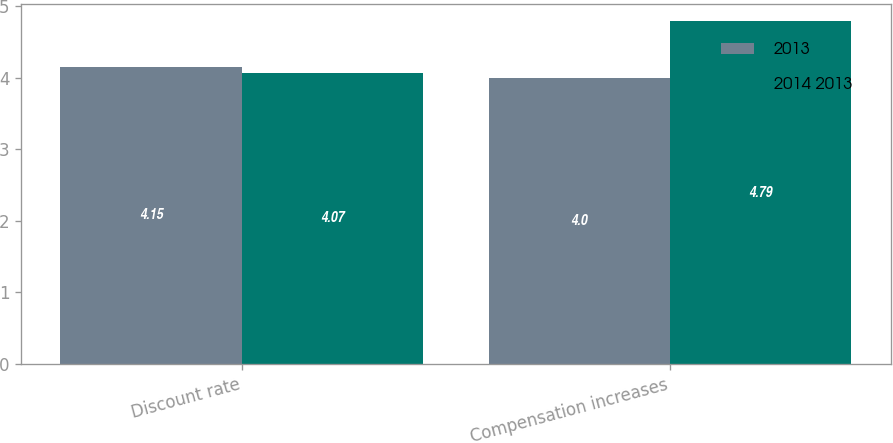<chart> <loc_0><loc_0><loc_500><loc_500><stacked_bar_chart><ecel><fcel>Discount rate<fcel>Compensation increases<nl><fcel>2013<fcel>4.15<fcel>4<nl><fcel>2014 2013<fcel>4.07<fcel>4.79<nl></chart> 